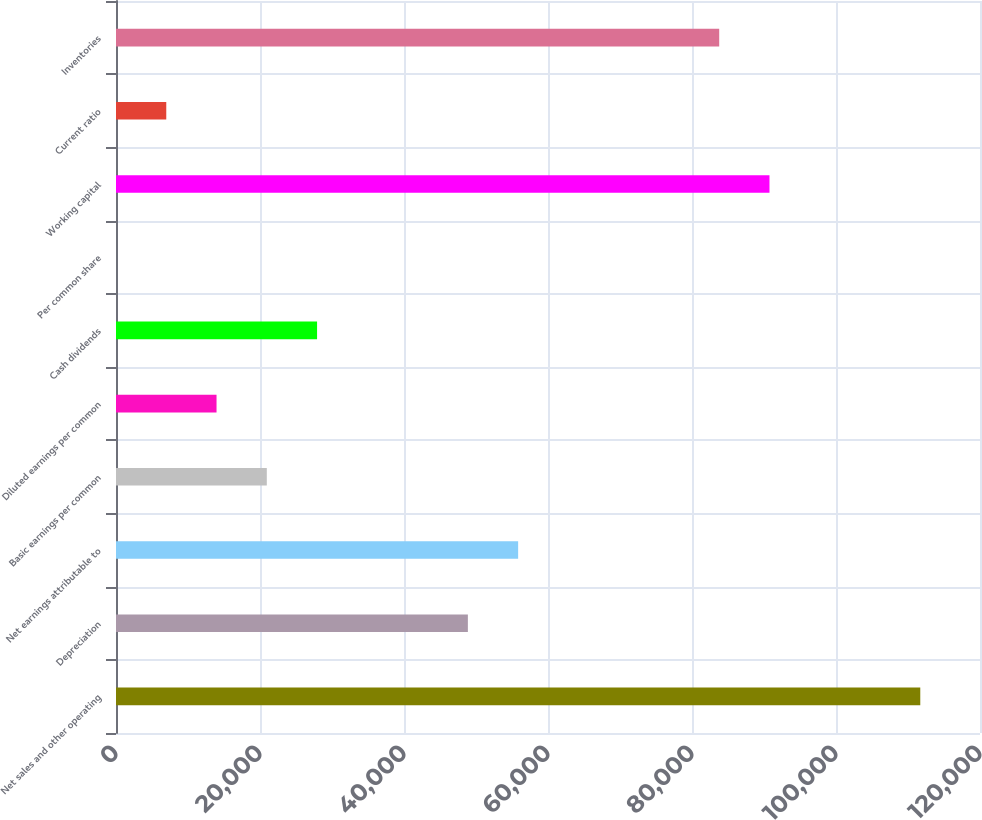Convert chart to OTSL. <chart><loc_0><loc_0><loc_500><loc_500><bar_chart><fcel>Net sales and other operating<fcel>Depreciation<fcel>Net earnings attributable to<fcel>Basic earnings per common<fcel>Diluted earnings per common<fcel>Cash dividends<fcel>Per common share<fcel>Working capital<fcel>Current ratio<fcel>Inventories<nl><fcel>111705<fcel>48871.3<fcel>55852.9<fcel>20945.1<fcel>13963.6<fcel>27926.7<fcel>0.49<fcel>90760.6<fcel>6982.04<fcel>83779.1<nl></chart> 